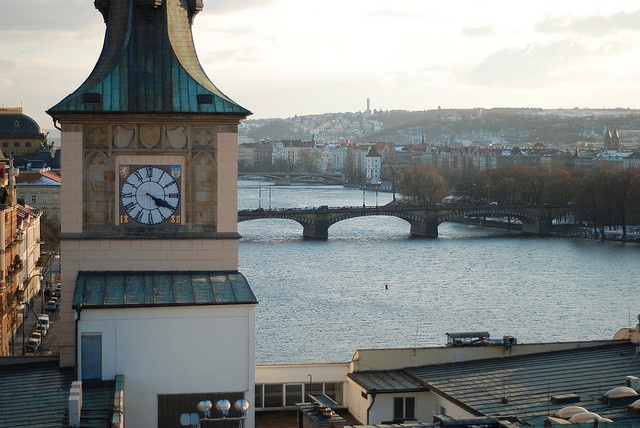Describe the objects in this image and their specific colors. I can see clock in darkgray, gray, and black tones, car in darkgray, black, and gray tones, car in darkgray, black, and gray tones, car in darkgray, black, blue, purple, and navy tones, and car in darkgray, black, gray, and maroon tones in this image. 